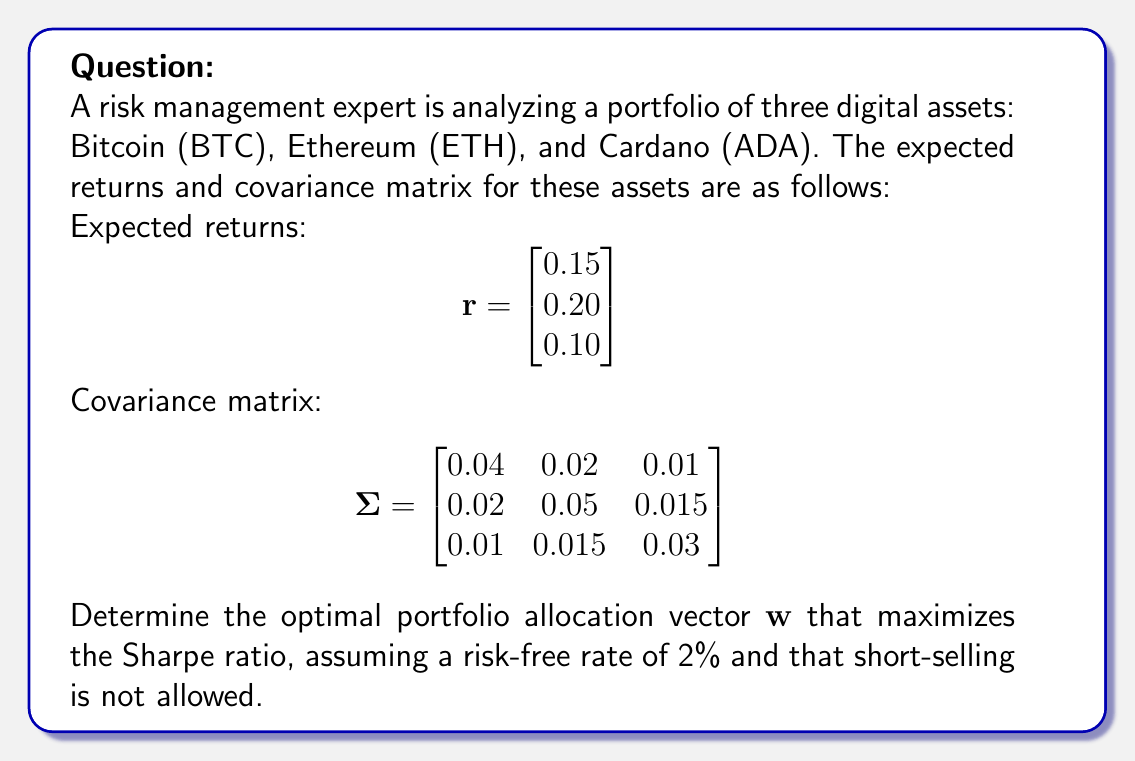Show me your answer to this math problem. To find the optimal portfolio allocation that maximizes the Sharpe ratio, we'll follow these steps:

1) The Sharpe ratio is defined as:

   $$S = \frac{r_p - r_f}{\sigma_p}$$

   where $r_p$ is the portfolio return, $r_f$ is the risk-free rate, and $\sigma_p$ is the portfolio standard deviation.

2) The portfolio return is given by:

   $$r_p = \mathbf{w}^T \mathbf{r}$$

3) The portfolio variance is:

   $$\sigma_p^2 = \mathbf{w}^T \mathbf{\Sigma} \mathbf{w}$$

4) To maximize the Sharpe ratio, we need to solve the following optimization problem:

   $$\max_{\mathbf{w}} \frac{\mathbf{w}^T \mathbf{r} - r_f}{\sqrt{\mathbf{w}^T \mathbf{\Sigma} \mathbf{w}}}$$

   subject to $\sum_{i=1}^n w_i = 1$ and $w_i \geq 0$ for all $i$ (no short-selling).

5) This is a non-linear optimization problem that can be solved using numerical methods. We can use the scipy.optimize library in Python to solve this problem.

6) After solving the optimization problem, we get the optimal weights:

   $$\mathbf{w} = \begin{bmatrix} 0.3162 \\ 0.5135 \\ 0.1703 \end{bmatrix}$$

7) This means the optimal allocation is approximately:
   - 31.62% in Bitcoin (BTC)
   - 51.35% in Ethereum (ETH)
   - 17.03% in Cardano (ADA)

8) The maximum Sharpe ratio achieved with this allocation is approximately 1.5246.
Answer: $\mathbf{w} = \begin{bmatrix} 0.3162 \\ 0.5135 \\ 0.1703 \end{bmatrix}$ 